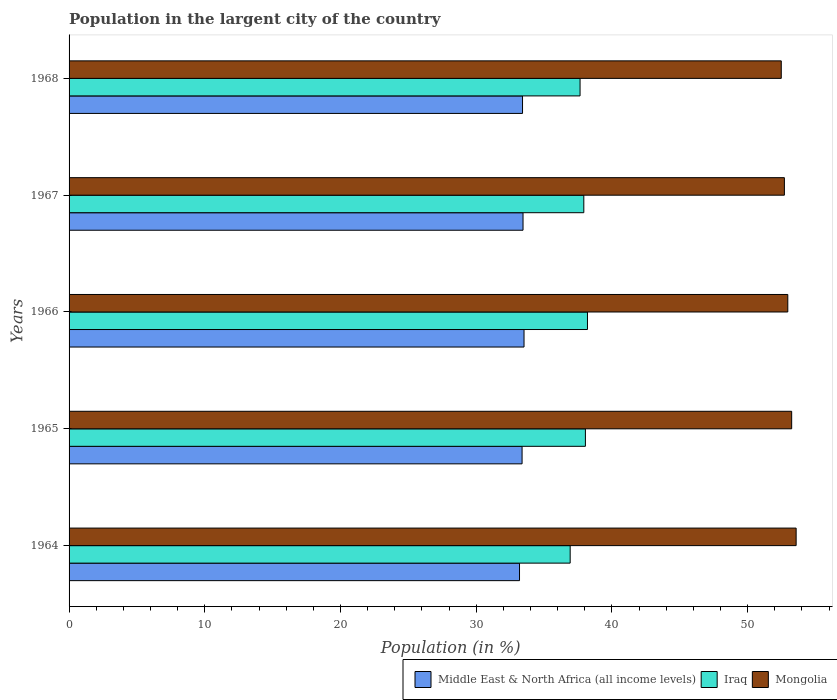How many groups of bars are there?
Make the answer very short. 5. Are the number of bars per tick equal to the number of legend labels?
Offer a terse response. Yes. Are the number of bars on each tick of the Y-axis equal?
Make the answer very short. Yes. How many bars are there on the 1st tick from the top?
Ensure brevity in your answer.  3. How many bars are there on the 5th tick from the bottom?
Your answer should be compact. 3. What is the label of the 5th group of bars from the top?
Offer a very short reply. 1964. What is the percentage of population in the largent city in Mongolia in 1966?
Ensure brevity in your answer.  52.96. Across all years, what is the maximum percentage of population in the largent city in Iraq?
Offer a terse response. 38.2. Across all years, what is the minimum percentage of population in the largent city in Iraq?
Offer a very short reply. 36.92. In which year was the percentage of population in the largent city in Iraq maximum?
Offer a terse response. 1966. In which year was the percentage of population in the largent city in Middle East & North Africa (all income levels) minimum?
Offer a very short reply. 1964. What is the total percentage of population in the largent city in Iraq in the graph?
Ensure brevity in your answer.  188.75. What is the difference between the percentage of population in the largent city in Iraq in 1966 and that in 1967?
Provide a short and direct response. 0.27. What is the difference between the percentage of population in the largent city in Middle East & North Africa (all income levels) in 1966 and the percentage of population in the largent city in Mongolia in 1965?
Make the answer very short. -19.72. What is the average percentage of population in the largent city in Iraq per year?
Provide a succinct answer. 37.75. In the year 1966, what is the difference between the percentage of population in the largent city in Iraq and percentage of population in the largent city in Middle East & North Africa (all income levels)?
Offer a very short reply. 4.67. What is the ratio of the percentage of population in the largent city in Iraq in 1966 to that in 1967?
Your answer should be compact. 1.01. Is the percentage of population in the largent city in Middle East & North Africa (all income levels) in 1964 less than that in 1968?
Keep it short and to the point. Yes. What is the difference between the highest and the second highest percentage of population in the largent city in Mongolia?
Your answer should be very brief. 0.33. What is the difference between the highest and the lowest percentage of population in the largent city in Iraq?
Provide a succinct answer. 1.27. What does the 3rd bar from the top in 1966 represents?
Give a very brief answer. Middle East & North Africa (all income levels). What does the 2nd bar from the bottom in 1965 represents?
Your answer should be very brief. Iraq. Is it the case that in every year, the sum of the percentage of population in the largent city in Iraq and percentage of population in the largent city in Middle East & North Africa (all income levels) is greater than the percentage of population in the largent city in Mongolia?
Make the answer very short. Yes. How many bars are there?
Offer a very short reply. 15. Are all the bars in the graph horizontal?
Provide a short and direct response. Yes. How many years are there in the graph?
Your response must be concise. 5. Are the values on the major ticks of X-axis written in scientific E-notation?
Make the answer very short. No. Where does the legend appear in the graph?
Your response must be concise. Bottom right. What is the title of the graph?
Offer a very short reply. Population in the largent city of the country. Does "Iceland" appear as one of the legend labels in the graph?
Offer a very short reply. No. What is the label or title of the X-axis?
Your answer should be very brief. Population (in %). What is the Population (in %) in Middle East & North Africa (all income levels) in 1964?
Make the answer very short. 33.19. What is the Population (in %) of Iraq in 1964?
Offer a very short reply. 36.92. What is the Population (in %) in Mongolia in 1964?
Offer a terse response. 53.58. What is the Population (in %) in Middle East & North Africa (all income levels) in 1965?
Provide a succinct answer. 33.38. What is the Population (in %) of Iraq in 1965?
Offer a terse response. 38.05. What is the Population (in %) of Mongolia in 1965?
Give a very brief answer. 53.25. What is the Population (in %) of Middle East & North Africa (all income levels) in 1966?
Your response must be concise. 33.52. What is the Population (in %) of Iraq in 1966?
Offer a very short reply. 38.2. What is the Population (in %) in Mongolia in 1966?
Keep it short and to the point. 52.96. What is the Population (in %) of Middle East & North Africa (all income levels) in 1967?
Provide a succinct answer. 33.45. What is the Population (in %) of Iraq in 1967?
Provide a short and direct response. 37.93. What is the Population (in %) in Mongolia in 1967?
Offer a terse response. 52.71. What is the Population (in %) in Middle East & North Africa (all income levels) in 1968?
Give a very brief answer. 33.41. What is the Population (in %) in Iraq in 1968?
Make the answer very short. 37.65. What is the Population (in %) of Mongolia in 1968?
Offer a terse response. 52.48. Across all years, what is the maximum Population (in %) of Middle East & North Africa (all income levels)?
Your answer should be compact. 33.52. Across all years, what is the maximum Population (in %) of Iraq?
Offer a terse response. 38.2. Across all years, what is the maximum Population (in %) of Mongolia?
Keep it short and to the point. 53.58. Across all years, what is the minimum Population (in %) in Middle East & North Africa (all income levels)?
Provide a short and direct response. 33.19. Across all years, what is the minimum Population (in %) of Iraq?
Give a very brief answer. 36.92. Across all years, what is the minimum Population (in %) of Mongolia?
Ensure brevity in your answer.  52.48. What is the total Population (in %) of Middle East & North Africa (all income levels) in the graph?
Your answer should be compact. 166.96. What is the total Population (in %) in Iraq in the graph?
Your response must be concise. 188.75. What is the total Population (in %) in Mongolia in the graph?
Give a very brief answer. 264.97. What is the difference between the Population (in %) of Middle East & North Africa (all income levels) in 1964 and that in 1965?
Provide a short and direct response. -0.19. What is the difference between the Population (in %) of Iraq in 1964 and that in 1965?
Make the answer very short. -1.12. What is the difference between the Population (in %) in Mongolia in 1964 and that in 1965?
Ensure brevity in your answer.  0.33. What is the difference between the Population (in %) of Middle East & North Africa (all income levels) in 1964 and that in 1966?
Your response must be concise. -0.33. What is the difference between the Population (in %) in Iraq in 1964 and that in 1966?
Provide a short and direct response. -1.27. What is the difference between the Population (in %) of Mongolia in 1964 and that in 1966?
Keep it short and to the point. 0.61. What is the difference between the Population (in %) in Middle East & North Africa (all income levels) in 1964 and that in 1967?
Your answer should be compact. -0.26. What is the difference between the Population (in %) of Iraq in 1964 and that in 1967?
Your answer should be very brief. -1. What is the difference between the Population (in %) in Mongolia in 1964 and that in 1967?
Offer a very short reply. 0.87. What is the difference between the Population (in %) of Middle East & North Africa (all income levels) in 1964 and that in 1968?
Offer a terse response. -0.22. What is the difference between the Population (in %) in Iraq in 1964 and that in 1968?
Provide a short and direct response. -0.73. What is the difference between the Population (in %) in Mongolia in 1964 and that in 1968?
Offer a terse response. 1.1. What is the difference between the Population (in %) of Middle East & North Africa (all income levels) in 1965 and that in 1966?
Keep it short and to the point. -0.14. What is the difference between the Population (in %) in Iraq in 1965 and that in 1966?
Provide a succinct answer. -0.15. What is the difference between the Population (in %) of Mongolia in 1965 and that in 1966?
Provide a short and direct response. 0.29. What is the difference between the Population (in %) of Middle East & North Africa (all income levels) in 1965 and that in 1967?
Your answer should be compact. -0.07. What is the difference between the Population (in %) in Iraq in 1965 and that in 1967?
Ensure brevity in your answer.  0.12. What is the difference between the Population (in %) in Mongolia in 1965 and that in 1967?
Provide a short and direct response. 0.54. What is the difference between the Population (in %) of Middle East & North Africa (all income levels) in 1965 and that in 1968?
Provide a succinct answer. -0.03. What is the difference between the Population (in %) of Iraq in 1965 and that in 1968?
Provide a succinct answer. 0.39. What is the difference between the Population (in %) of Mongolia in 1965 and that in 1968?
Provide a short and direct response. 0.77. What is the difference between the Population (in %) of Middle East & North Africa (all income levels) in 1966 and that in 1967?
Offer a very short reply. 0.07. What is the difference between the Population (in %) of Iraq in 1966 and that in 1967?
Ensure brevity in your answer.  0.27. What is the difference between the Population (in %) in Mongolia in 1966 and that in 1967?
Offer a very short reply. 0.25. What is the difference between the Population (in %) of Middle East & North Africa (all income levels) in 1966 and that in 1968?
Make the answer very short. 0.11. What is the difference between the Population (in %) in Iraq in 1966 and that in 1968?
Make the answer very short. 0.54. What is the difference between the Population (in %) of Mongolia in 1966 and that in 1968?
Give a very brief answer. 0.48. What is the difference between the Population (in %) in Middle East & North Africa (all income levels) in 1967 and that in 1968?
Make the answer very short. 0.04. What is the difference between the Population (in %) in Iraq in 1967 and that in 1968?
Offer a very short reply. 0.28. What is the difference between the Population (in %) in Mongolia in 1967 and that in 1968?
Your answer should be very brief. 0.23. What is the difference between the Population (in %) of Middle East & North Africa (all income levels) in 1964 and the Population (in %) of Iraq in 1965?
Provide a succinct answer. -4.85. What is the difference between the Population (in %) of Middle East & North Africa (all income levels) in 1964 and the Population (in %) of Mongolia in 1965?
Ensure brevity in your answer.  -20.05. What is the difference between the Population (in %) in Iraq in 1964 and the Population (in %) in Mongolia in 1965?
Offer a very short reply. -16.32. What is the difference between the Population (in %) in Middle East & North Africa (all income levels) in 1964 and the Population (in %) in Iraq in 1966?
Your answer should be compact. -5.01. What is the difference between the Population (in %) of Middle East & North Africa (all income levels) in 1964 and the Population (in %) of Mongolia in 1966?
Keep it short and to the point. -19.77. What is the difference between the Population (in %) of Iraq in 1964 and the Population (in %) of Mongolia in 1966?
Provide a short and direct response. -16.04. What is the difference between the Population (in %) of Middle East & North Africa (all income levels) in 1964 and the Population (in %) of Iraq in 1967?
Keep it short and to the point. -4.74. What is the difference between the Population (in %) in Middle East & North Africa (all income levels) in 1964 and the Population (in %) in Mongolia in 1967?
Ensure brevity in your answer.  -19.52. What is the difference between the Population (in %) in Iraq in 1964 and the Population (in %) in Mongolia in 1967?
Provide a succinct answer. -15.78. What is the difference between the Population (in %) of Middle East & North Africa (all income levels) in 1964 and the Population (in %) of Iraq in 1968?
Offer a terse response. -4.46. What is the difference between the Population (in %) in Middle East & North Africa (all income levels) in 1964 and the Population (in %) in Mongolia in 1968?
Provide a short and direct response. -19.29. What is the difference between the Population (in %) of Iraq in 1964 and the Population (in %) of Mongolia in 1968?
Your answer should be very brief. -15.56. What is the difference between the Population (in %) of Middle East & North Africa (all income levels) in 1965 and the Population (in %) of Iraq in 1966?
Provide a succinct answer. -4.82. What is the difference between the Population (in %) in Middle East & North Africa (all income levels) in 1965 and the Population (in %) in Mongolia in 1966?
Your response must be concise. -19.58. What is the difference between the Population (in %) of Iraq in 1965 and the Population (in %) of Mongolia in 1966?
Keep it short and to the point. -14.91. What is the difference between the Population (in %) in Middle East & North Africa (all income levels) in 1965 and the Population (in %) in Iraq in 1967?
Make the answer very short. -4.55. What is the difference between the Population (in %) of Middle East & North Africa (all income levels) in 1965 and the Population (in %) of Mongolia in 1967?
Your answer should be very brief. -19.33. What is the difference between the Population (in %) of Iraq in 1965 and the Population (in %) of Mongolia in 1967?
Keep it short and to the point. -14.66. What is the difference between the Population (in %) in Middle East & North Africa (all income levels) in 1965 and the Population (in %) in Iraq in 1968?
Make the answer very short. -4.27. What is the difference between the Population (in %) in Middle East & North Africa (all income levels) in 1965 and the Population (in %) in Mongolia in 1968?
Provide a succinct answer. -19.1. What is the difference between the Population (in %) in Iraq in 1965 and the Population (in %) in Mongolia in 1968?
Ensure brevity in your answer.  -14.43. What is the difference between the Population (in %) in Middle East & North Africa (all income levels) in 1966 and the Population (in %) in Iraq in 1967?
Your response must be concise. -4.41. What is the difference between the Population (in %) of Middle East & North Africa (all income levels) in 1966 and the Population (in %) of Mongolia in 1967?
Offer a very short reply. -19.19. What is the difference between the Population (in %) in Iraq in 1966 and the Population (in %) in Mongolia in 1967?
Your answer should be very brief. -14.51. What is the difference between the Population (in %) in Middle East & North Africa (all income levels) in 1966 and the Population (in %) in Iraq in 1968?
Keep it short and to the point. -4.13. What is the difference between the Population (in %) in Middle East & North Africa (all income levels) in 1966 and the Population (in %) in Mongolia in 1968?
Your answer should be compact. -18.96. What is the difference between the Population (in %) in Iraq in 1966 and the Population (in %) in Mongolia in 1968?
Provide a succinct answer. -14.28. What is the difference between the Population (in %) of Middle East & North Africa (all income levels) in 1967 and the Population (in %) of Iraq in 1968?
Make the answer very short. -4.2. What is the difference between the Population (in %) in Middle East & North Africa (all income levels) in 1967 and the Population (in %) in Mongolia in 1968?
Make the answer very short. -19.03. What is the difference between the Population (in %) in Iraq in 1967 and the Population (in %) in Mongolia in 1968?
Ensure brevity in your answer.  -14.55. What is the average Population (in %) in Middle East & North Africa (all income levels) per year?
Your answer should be very brief. 33.39. What is the average Population (in %) of Iraq per year?
Ensure brevity in your answer.  37.75. What is the average Population (in %) of Mongolia per year?
Keep it short and to the point. 52.99. In the year 1964, what is the difference between the Population (in %) in Middle East & North Africa (all income levels) and Population (in %) in Iraq?
Offer a very short reply. -3.73. In the year 1964, what is the difference between the Population (in %) of Middle East & North Africa (all income levels) and Population (in %) of Mongolia?
Your answer should be very brief. -20.38. In the year 1964, what is the difference between the Population (in %) of Iraq and Population (in %) of Mongolia?
Your answer should be very brief. -16.65. In the year 1965, what is the difference between the Population (in %) of Middle East & North Africa (all income levels) and Population (in %) of Iraq?
Keep it short and to the point. -4.67. In the year 1965, what is the difference between the Population (in %) of Middle East & North Africa (all income levels) and Population (in %) of Mongolia?
Provide a succinct answer. -19.87. In the year 1965, what is the difference between the Population (in %) in Iraq and Population (in %) in Mongolia?
Offer a terse response. -15.2. In the year 1966, what is the difference between the Population (in %) of Middle East & North Africa (all income levels) and Population (in %) of Iraq?
Provide a short and direct response. -4.67. In the year 1966, what is the difference between the Population (in %) in Middle East & North Africa (all income levels) and Population (in %) in Mongolia?
Ensure brevity in your answer.  -19.44. In the year 1966, what is the difference between the Population (in %) of Iraq and Population (in %) of Mongolia?
Give a very brief answer. -14.76. In the year 1967, what is the difference between the Population (in %) of Middle East & North Africa (all income levels) and Population (in %) of Iraq?
Give a very brief answer. -4.48. In the year 1967, what is the difference between the Population (in %) in Middle East & North Africa (all income levels) and Population (in %) in Mongolia?
Offer a terse response. -19.26. In the year 1967, what is the difference between the Population (in %) of Iraq and Population (in %) of Mongolia?
Keep it short and to the point. -14.78. In the year 1968, what is the difference between the Population (in %) in Middle East & North Africa (all income levels) and Population (in %) in Iraq?
Your answer should be compact. -4.24. In the year 1968, what is the difference between the Population (in %) in Middle East & North Africa (all income levels) and Population (in %) in Mongolia?
Your answer should be very brief. -19.07. In the year 1968, what is the difference between the Population (in %) of Iraq and Population (in %) of Mongolia?
Keep it short and to the point. -14.83. What is the ratio of the Population (in %) of Middle East & North Africa (all income levels) in 1964 to that in 1965?
Your answer should be compact. 0.99. What is the ratio of the Population (in %) in Iraq in 1964 to that in 1965?
Keep it short and to the point. 0.97. What is the ratio of the Population (in %) in Mongolia in 1964 to that in 1965?
Offer a terse response. 1.01. What is the ratio of the Population (in %) of Middle East & North Africa (all income levels) in 1964 to that in 1966?
Offer a very short reply. 0.99. What is the ratio of the Population (in %) in Iraq in 1964 to that in 1966?
Provide a short and direct response. 0.97. What is the ratio of the Population (in %) of Mongolia in 1964 to that in 1966?
Give a very brief answer. 1.01. What is the ratio of the Population (in %) of Middle East & North Africa (all income levels) in 1964 to that in 1967?
Your response must be concise. 0.99. What is the ratio of the Population (in %) of Iraq in 1964 to that in 1967?
Your answer should be compact. 0.97. What is the ratio of the Population (in %) of Mongolia in 1964 to that in 1967?
Provide a short and direct response. 1.02. What is the ratio of the Population (in %) in Iraq in 1964 to that in 1968?
Your answer should be compact. 0.98. What is the ratio of the Population (in %) of Mongolia in 1964 to that in 1968?
Your answer should be compact. 1.02. What is the ratio of the Population (in %) in Middle East & North Africa (all income levels) in 1965 to that in 1966?
Your answer should be compact. 1. What is the ratio of the Population (in %) of Mongolia in 1965 to that in 1966?
Your response must be concise. 1.01. What is the ratio of the Population (in %) in Mongolia in 1965 to that in 1967?
Your answer should be very brief. 1.01. What is the ratio of the Population (in %) in Middle East & North Africa (all income levels) in 1965 to that in 1968?
Provide a succinct answer. 1. What is the ratio of the Population (in %) in Iraq in 1965 to that in 1968?
Ensure brevity in your answer.  1.01. What is the ratio of the Population (in %) in Mongolia in 1965 to that in 1968?
Provide a succinct answer. 1.01. What is the ratio of the Population (in %) in Iraq in 1966 to that in 1967?
Your answer should be very brief. 1.01. What is the ratio of the Population (in %) in Middle East & North Africa (all income levels) in 1966 to that in 1968?
Make the answer very short. 1. What is the ratio of the Population (in %) of Iraq in 1966 to that in 1968?
Make the answer very short. 1.01. What is the ratio of the Population (in %) of Mongolia in 1966 to that in 1968?
Ensure brevity in your answer.  1.01. What is the ratio of the Population (in %) of Iraq in 1967 to that in 1968?
Offer a very short reply. 1.01. What is the ratio of the Population (in %) of Mongolia in 1967 to that in 1968?
Your answer should be very brief. 1. What is the difference between the highest and the second highest Population (in %) of Middle East & North Africa (all income levels)?
Offer a terse response. 0.07. What is the difference between the highest and the second highest Population (in %) of Iraq?
Provide a short and direct response. 0.15. What is the difference between the highest and the second highest Population (in %) in Mongolia?
Make the answer very short. 0.33. What is the difference between the highest and the lowest Population (in %) of Middle East & North Africa (all income levels)?
Make the answer very short. 0.33. What is the difference between the highest and the lowest Population (in %) in Iraq?
Your answer should be compact. 1.27. What is the difference between the highest and the lowest Population (in %) of Mongolia?
Offer a terse response. 1.1. 